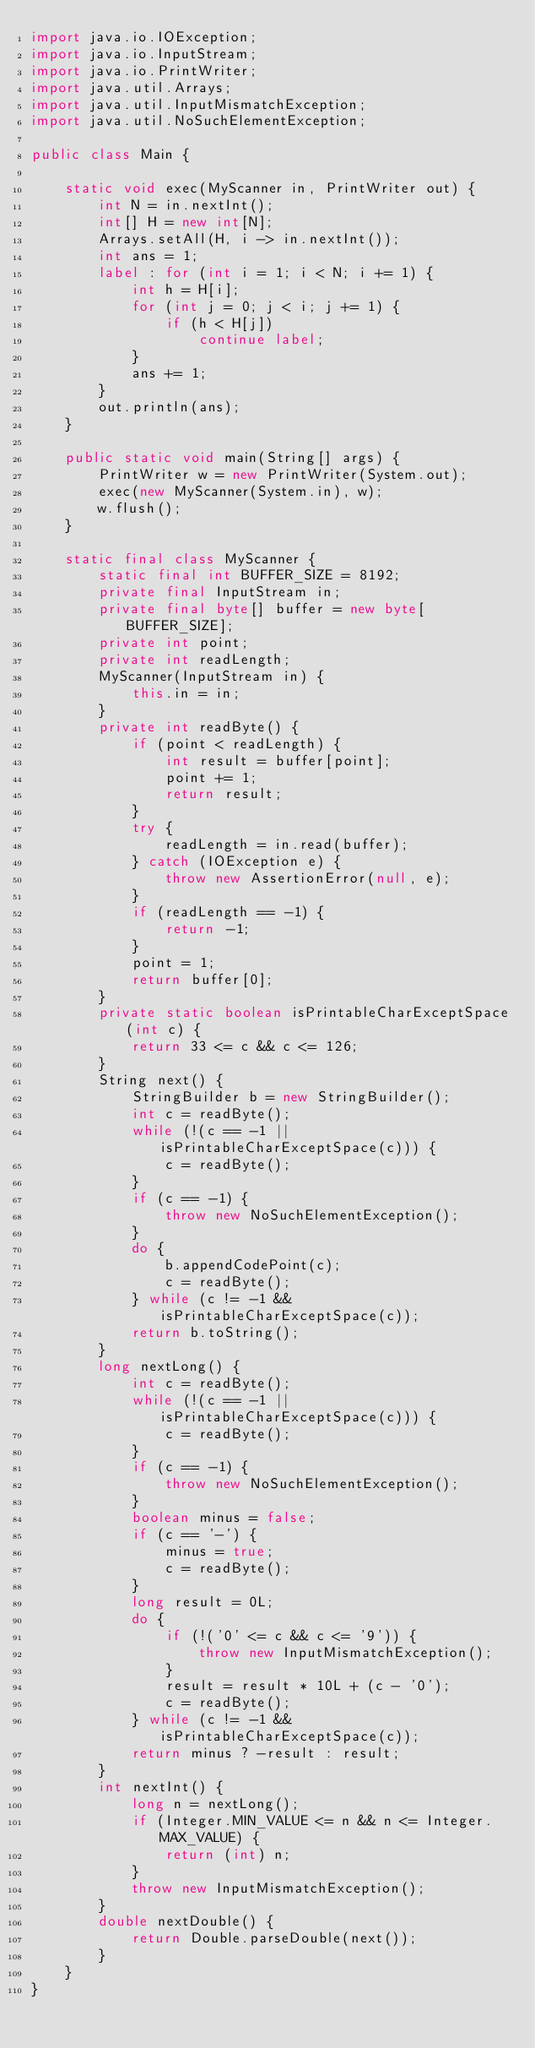Convert code to text. <code><loc_0><loc_0><loc_500><loc_500><_Java_>import java.io.IOException;
import java.io.InputStream;
import java.io.PrintWriter;
import java.util.Arrays;
import java.util.InputMismatchException;
import java.util.NoSuchElementException;

public class Main {

    static void exec(MyScanner in, PrintWriter out) {
        int N = in.nextInt();
        int[] H = new int[N];
        Arrays.setAll(H, i -> in.nextInt());
        int ans = 1;
        label : for (int i = 1; i < N; i += 1) {
            int h = H[i];
            for (int j = 0; j < i; j += 1) {
                if (h < H[j])
                    continue label;
            }
            ans += 1;
        }
        out.println(ans);
    }

    public static void main(String[] args) {
        PrintWriter w = new PrintWriter(System.out);
        exec(new MyScanner(System.in), w);
        w.flush();
    }

    static final class MyScanner {
        static final int BUFFER_SIZE = 8192;
        private final InputStream in;
        private final byte[] buffer = new byte[BUFFER_SIZE];
        private int point;
        private int readLength;
        MyScanner(InputStream in) {
            this.in = in;
        }
        private int readByte() {
            if (point < readLength) {
                int result = buffer[point];
                point += 1;
                return result;
            }
            try {
                readLength = in.read(buffer);
            } catch (IOException e) {
                throw new AssertionError(null, e);
            }
            if (readLength == -1) {
                return -1;
            }
            point = 1;
            return buffer[0];
        }
        private static boolean isPrintableCharExceptSpace(int c) {
            return 33 <= c && c <= 126;
        }
        String next() {
            StringBuilder b = new StringBuilder();
            int c = readByte();
            while (!(c == -1 || isPrintableCharExceptSpace(c))) {
                c = readByte();
            }
            if (c == -1) {
                throw new NoSuchElementException();
            }
            do {
                b.appendCodePoint(c);
                c = readByte();
            } while (c != -1 && isPrintableCharExceptSpace(c));
            return b.toString();
        }
        long nextLong() {
            int c = readByte();
            while (!(c == -1 || isPrintableCharExceptSpace(c))) {
                c = readByte();
            }
            if (c == -1) {
                throw new NoSuchElementException();
            }
            boolean minus = false;
            if (c == '-') {
                minus = true;
                c = readByte();
            }
            long result = 0L;
            do {
                if (!('0' <= c && c <= '9')) {
                    throw new InputMismatchException();
                }
                result = result * 10L + (c - '0');
                c = readByte();
            } while (c != -1 && isPrintableCharExceptSpace(c));
            return minus ? -result : result;
        }
        int nextInt() {
            long n = nextLong();
            if (Integer.MIN_VALUE <= n && n <= Integer.MAX_VALUE) {
                return (int) n;
            }
            throw new InputMismatchException();
        }
        double nextDouble() {
            return Double.parseDouble(next());
        }
    }
}
</code> 